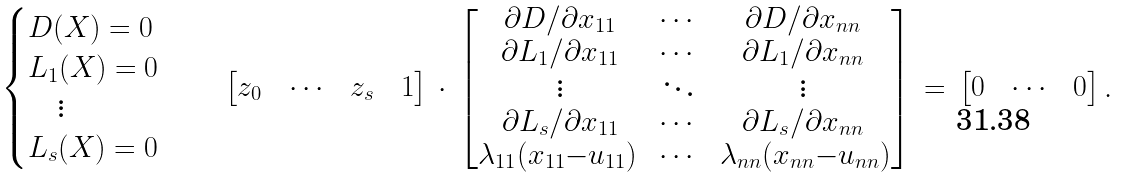Convert formula to latex. <formula><loc_0><loc_0><loc_500><loc_500>\, \begin{cases} D ( X ) = 0 \\ L _ { 1 } ( X ) = 0 \\ \quad \vdots \\ L _ { s } ( X ) = 0 \end{cases} \quad \begin{bmatrix} z _ { 0 } \, & \, \cdots \, & \, z _ { s } \, & \, 1 \end{bmatrix} \, \cdot \, \begin{bmatrix} \partial D / \partial x _ { 1 1 } & \cdots & \partial D / \partial x _ { n n } \\ \partial L _ { 1 } / \partial x _ { 1 1 } & \cdots & \partial L _ { 1 } / \partial x _ { n n } \\ \vdots & \ddots & \vdots \\ \partial L _ { s } / \partial x _ { 1 1 } & \cdots & \partial L _ { s } / \partial x _ { n n } \\ \lambda _ { 1 1 } ( x _ { 1 1 } { - } u _ { 1 1 } ) \, & \cdots & \, \lambda _ { n n } ( x _ { n n } { - } u _ { n n } ) \end{bmatrix} \, = \, \begin{bmatrix} 0 \, & \, \cdots \, & \, 0 \end{bmatrix} .</formula> 